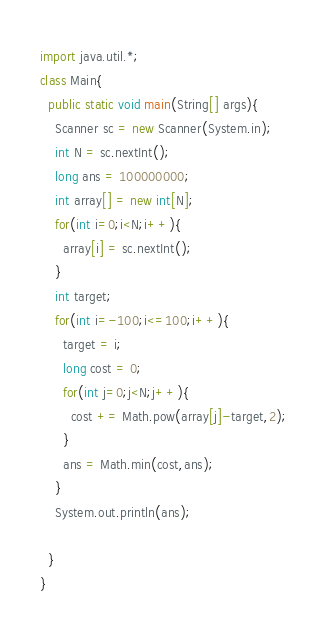Convert code to text. <code><loc_0><loc_0><loc_500><loc_500><_Java_>import java.util.*;
class Main{
  public static void main(String[] args){
    Scanner sc = new Scanner(System.in);
    int N = sc.nextInt();
    long ans = 100000000;
    int array[] = new int[N];
    for(int i=0;i<N;i++){
      array[i] = sc.nextInt();
    }
    int target;
    for(int i=-100;i<=100;i++){
      target = i;
      long cost = 0;
      for(int j=0;j<N;j++){
        cost += Math.pow(array[j]-target,2);
      }
      ans = Math.min(cost,ans);
    }
    System.out.println(ans);

  }
}</code> 